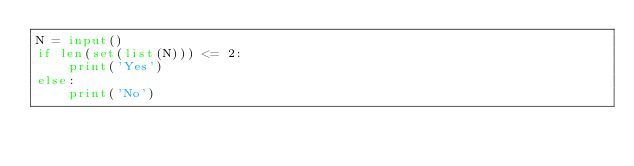<code> <loc_0><loc_0><loc_500><loc_500><_Python_>N = input()
if len(set(list(N))) <= 2:
    print('Yes')
else:
    print('No')</code> 